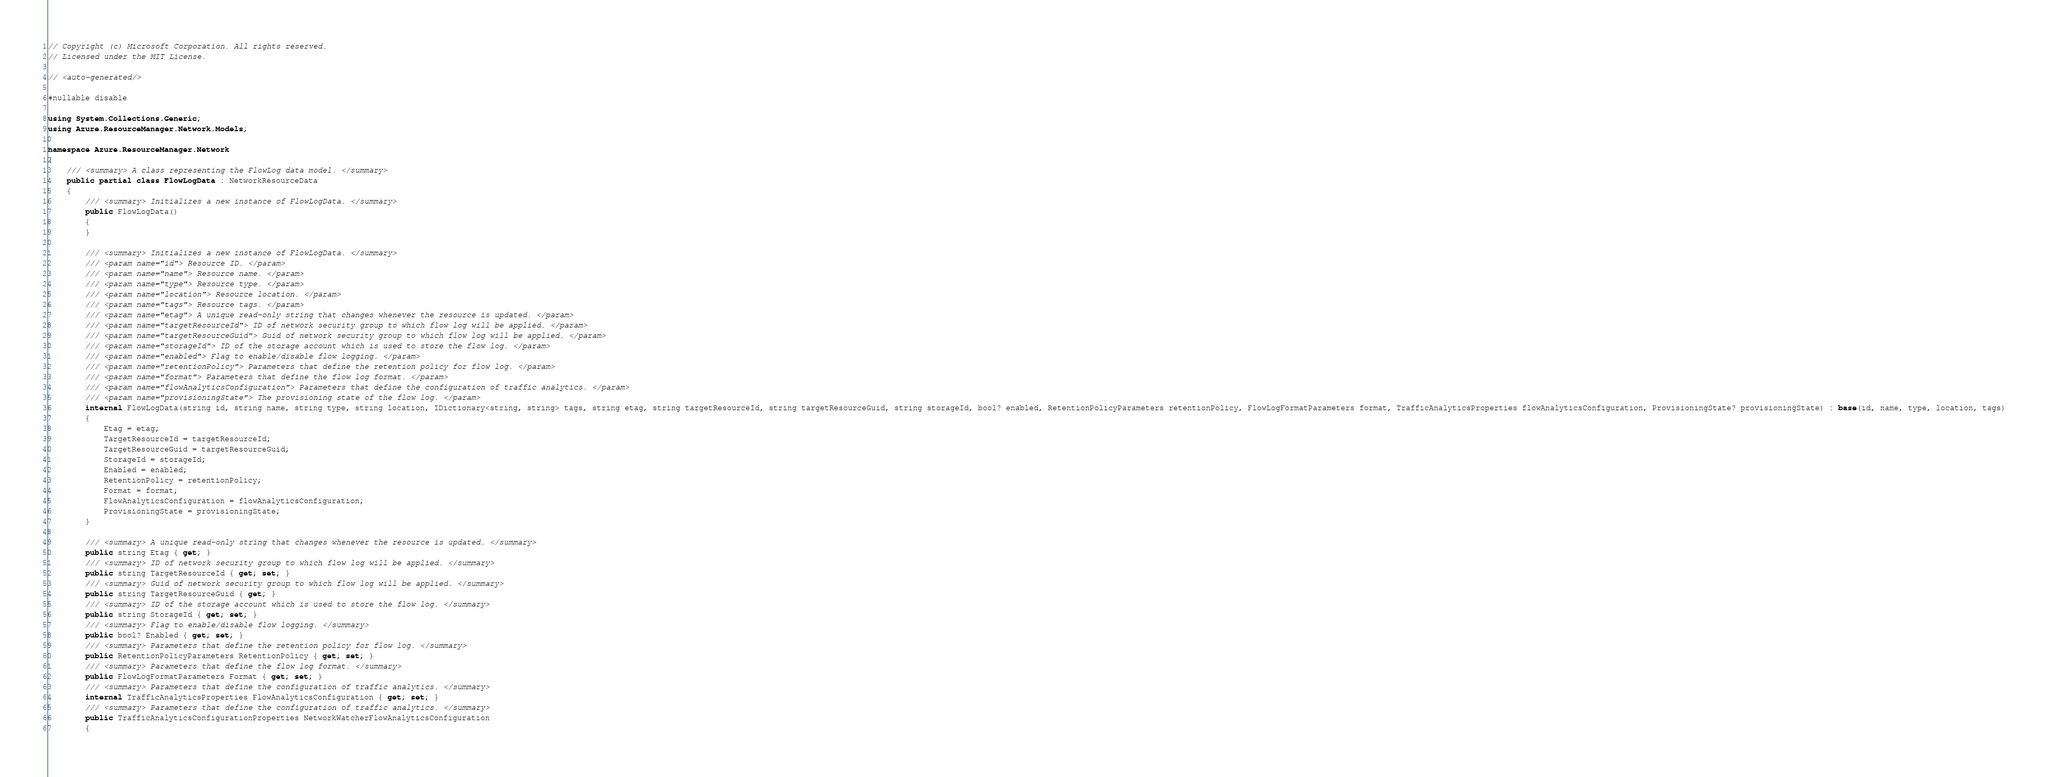<code> <loc_0><loc_0><loc_500><loc_500><_C#_>// Copyright (c) Microsoft Corporation. All rights reserved.
// Licensed under the MIT License.

// <auto-generated/>

#nullable disable

using System.Collections.Generic;
using Azure.ResourceManager.Network.Models;

namespace Azure.ResourceManager.Network
{
    /// <summary> A class representing the FlowLog data model. </summary>
    public partial class FlowLogData : NetworkResourceData
    {
        /// <summary> Initializes a new instance of FlowLogData. </summary>
        public FlowLogData()
        {
        }

        /// <summary> Initializes a new instance of FlowLogData. </summary>
        /// <param name="id"> Resource ID. </param>
        /// <param name="name"> Resource name. </param>
        /// <param name="type"> Resource type. </param>
        /// <param name="location"> Resource location. </param>
        /// <param name="tags"> Resource tags. </param>
        /// <param name="etag"> A unique read-only string that changes whenever the resource is updated. </param>
        /// <param name="targetResourceId"> ID of network security group to which flow log will be applied. </param>
        /// <param name="targetResourceGuid"> Guid of network security group to which flow log will be applied. </param>
        /// <param name="storageId"> ID of the storage account which is used to store the flow log. </param>
        /// <param name="enabled"> Flag to enable/disable flow logging. </param>
        /// <param name="retentionPolicy"> Parameters that define the retention policy for flow log. </param>
        /// <param name="format"> Parameters that define the flow log format. </param>
        /// <param name="flowAnalyticsConfiguration"> Parameters that define the configuration of traffic analytics. </param>
        /// <param name="provisioningState"> The provisioning state of the flow log. </param>
        internal FlowLogData(string id, string name, string type, string location, IDictionary<string, string> tags, string etag, string targetResourceId, string targetResourceGuid, string storageId, bool? enabled, RetentionPolicyParameters retentionPolicy, FlowLogFormatParameters format, TrafficAnalyticsProperties flowAnalyticsConfiguration, ProvisioningState? provisioningState) : base(id, name, type, location, tags)
        {
            Etag = etag;
            TargetResourceId = targetResourceId;
            TargetResourceGuid = targetResourceGuid;
            StorageId = storageId;
            Enabled = enabled;
            RetentionPolicy = retentionPolicy;
            Format = format;
            FlowAnalyticsConfiguration = flowAnalyticsConfiguration;
            ProvisioningState = provisioningState;
        }

        /// <summary> A unique read-only string that changes whenever the resource is updated. </summary>
        public string Etag { get; }
        /// <summary> ID of network security group to which flow log will be applied. </summary>
        public string TargetResourceId { get; set; }
        /// <summary> Guid of network security group to which flow log will be applied. </summary>
        public string TargetResourceGuid { get; }
        /// <summary> ID of the storage account which is used to store the flow log. </summary>
        public string StorageId { get; set; }
        /// <summary> Flag to enable/disable flow logging. </summary>
        public bool? Enabled { get; set; }
        /// <summary> Parameters that define the retention policy for flow log. </summary>
        public RetentionPolicyParameters RetentionPolicy { get; set; }
        /// <summary> Parameters that define the flow log format. </summary>
        public FlowLogFormatParameters Format { get; set; }
        /// <summary> Parameters that define the configuration of traffic analytics. </summary>
        internal TrafficAnalyticsProperties FlowAnalyticsConfiguration { get; set; }
        /// <summary> Parameters that define the configuration of traffic analytics. </summary>
        public TrafficAnalyticsConfigurationProperties NetworkWatcherFlowAnalyticsConfiguration
        {</code> 